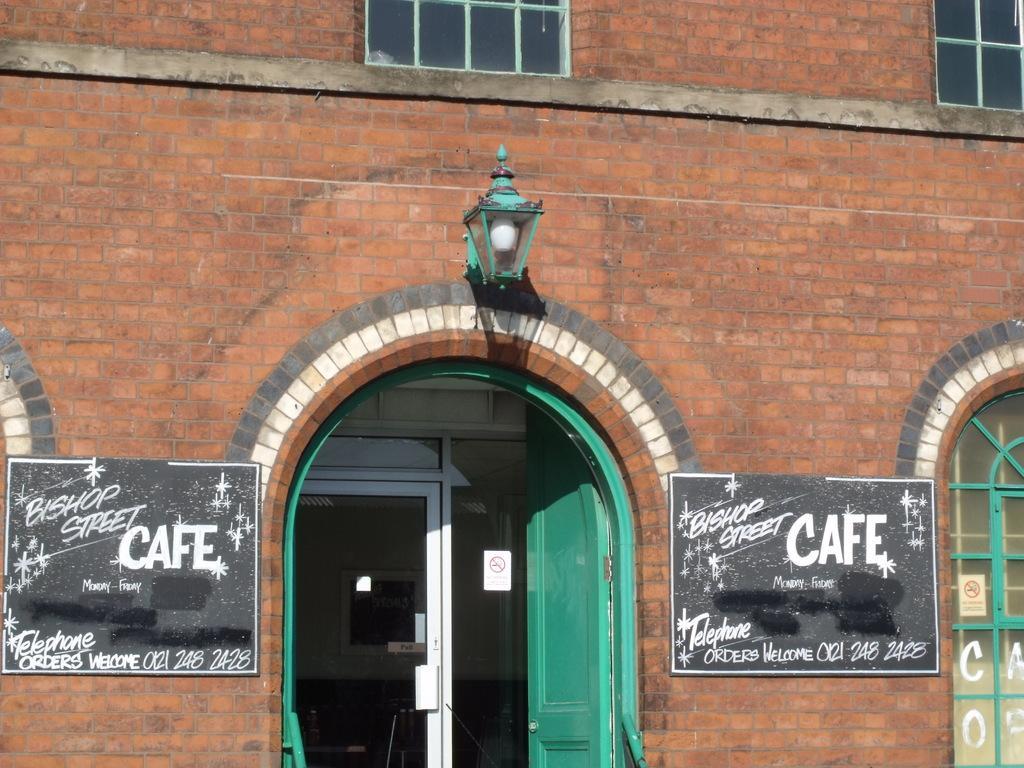In one or two sentences, can you explain what this image depicts? In this picture, we see a building in brown color which is made up of bricks. In the middle of the picture, we see the lights and a green door. On either side of the picture, we see the boards in black color with some text written on it. On the right side, we see a door. At the top, we see the windows. 